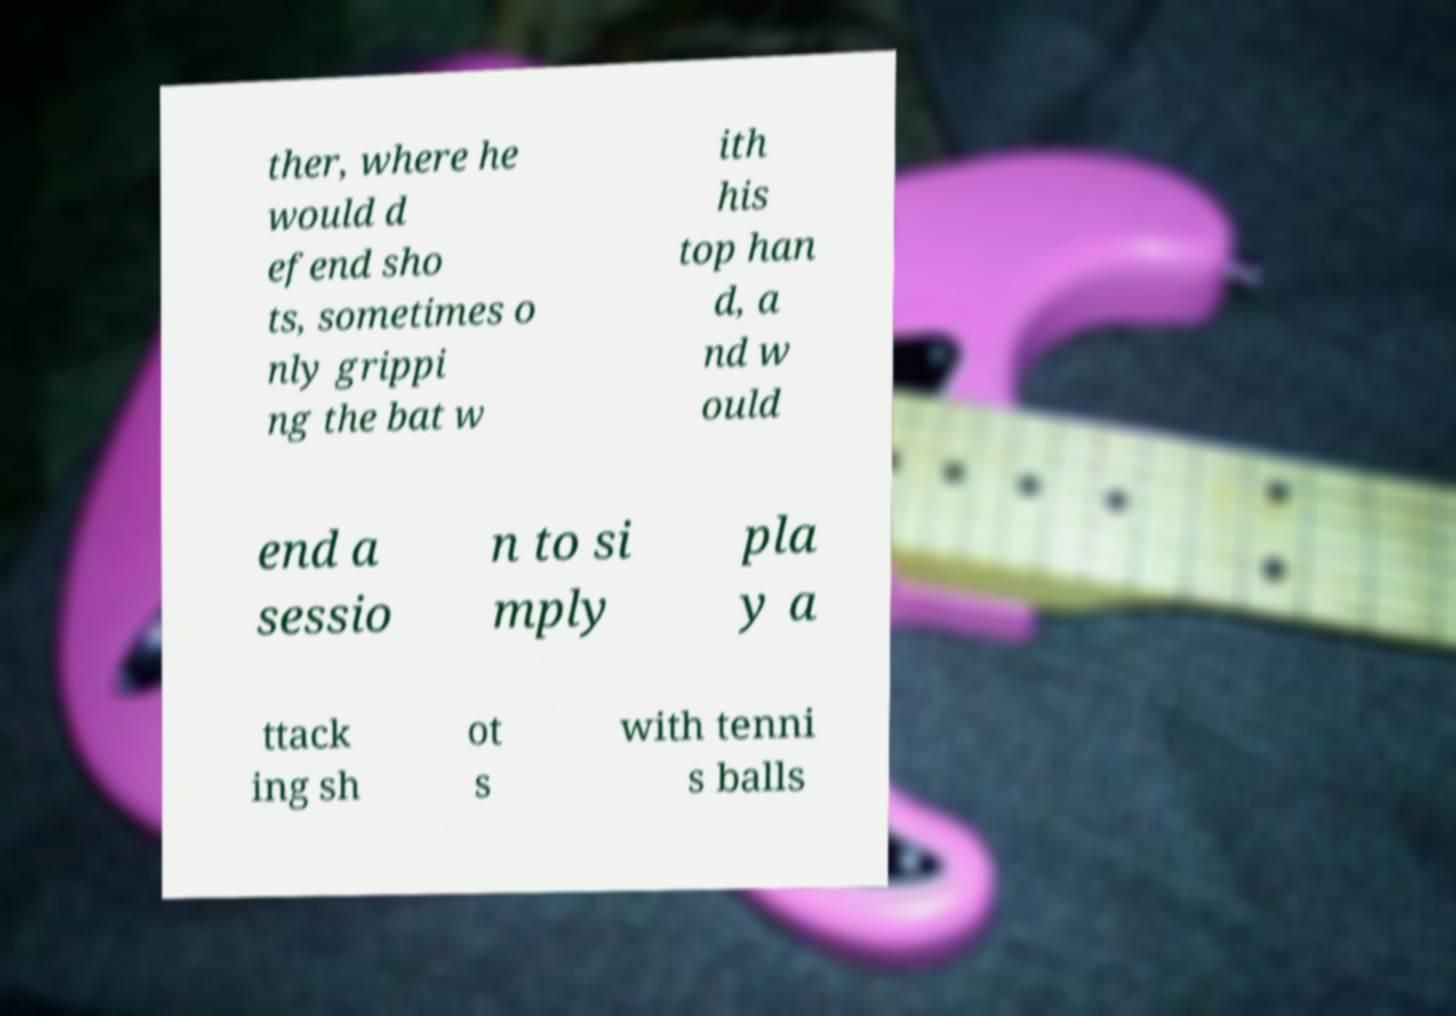There's text embedded in this image that I need extracted. Can you transcribe it verbatim? ther, where he would d efend sho ts, sometimes o nly grippi ng the bat w ith his top han d, a nd w ould end a sessio n to si mply pla y a ttack ing sh ot s with tenni s balls 